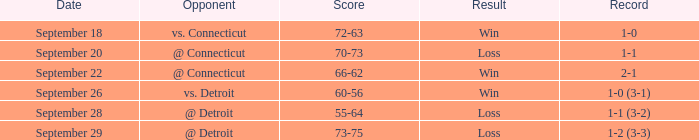When was the date that had a score of 66-62? September 22. 